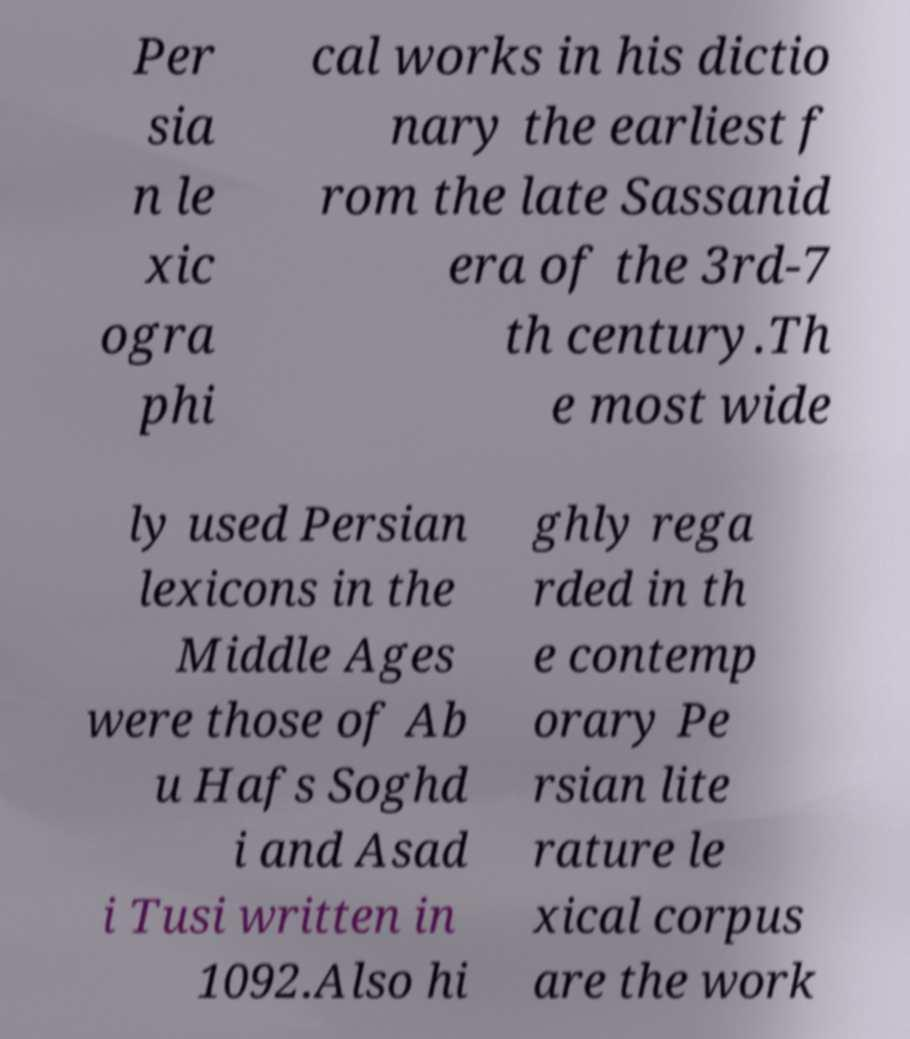Can you read and provide the text displayed in the image?This photo seems to have some interesting text. Can you extract and type it out for me? Per sia n le xic ogra phi cal works in his dictio nary the earliest f rom the late Sassanid era of the 3rd-7 th century.Th e most wide ly used Persian lexicons in the Middle Ages were those of Ab u Hafs Soghd i and Asad i Tusi written in 1092.Also hi ghly rega rded in th e contemp orary Pe rsian lite rature le xical corpus are the work 